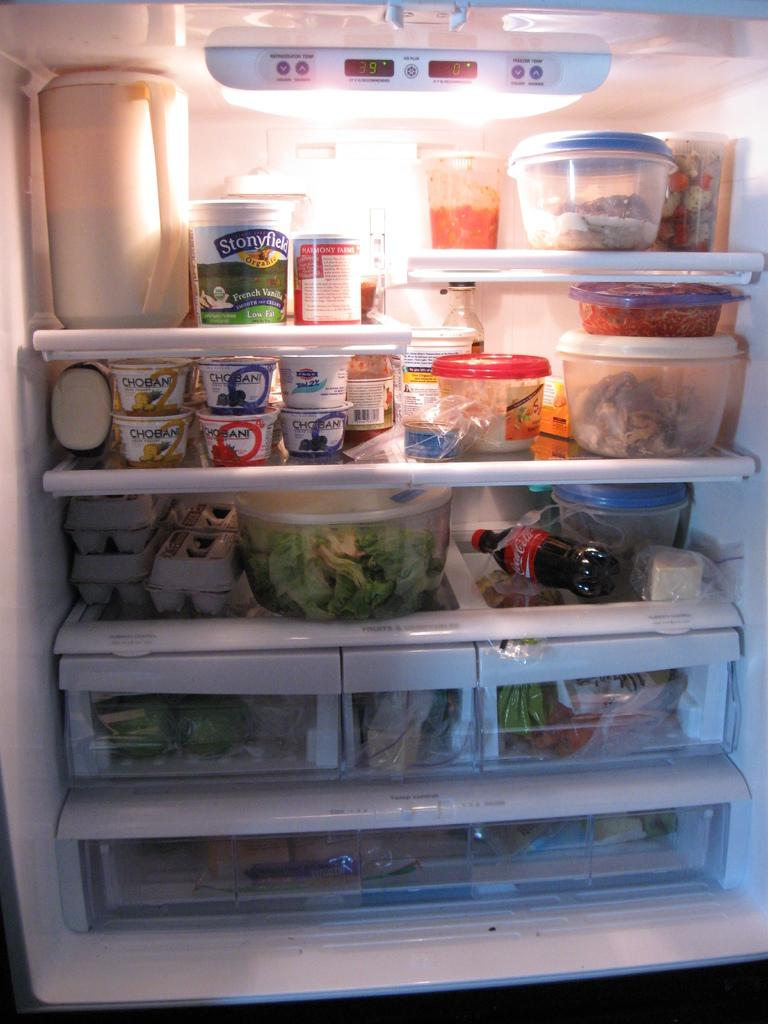<image>
Describe the image concisely. a little blue container with Chobani written on it 